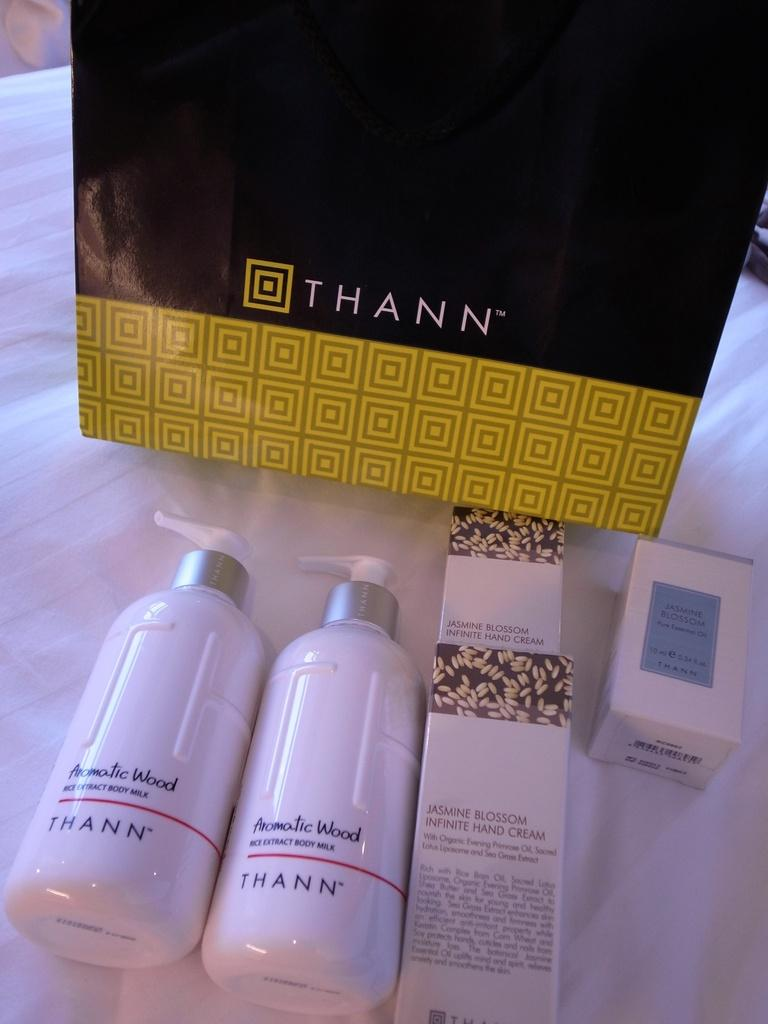How many bottles can be seen in the image? There are two bottles in the image. What else is present in the image besides the bottles? There is a cover in the image. Where are the bottles and cover located? The bottles and cover are on a bed. What type of park is visible in the image? There is no park present in the image; it features two bottles and a cover on a bed. What scientific theory can be observed in the image? There is no scientific theory present in the image; it features two bottles and a cover on a bed. 